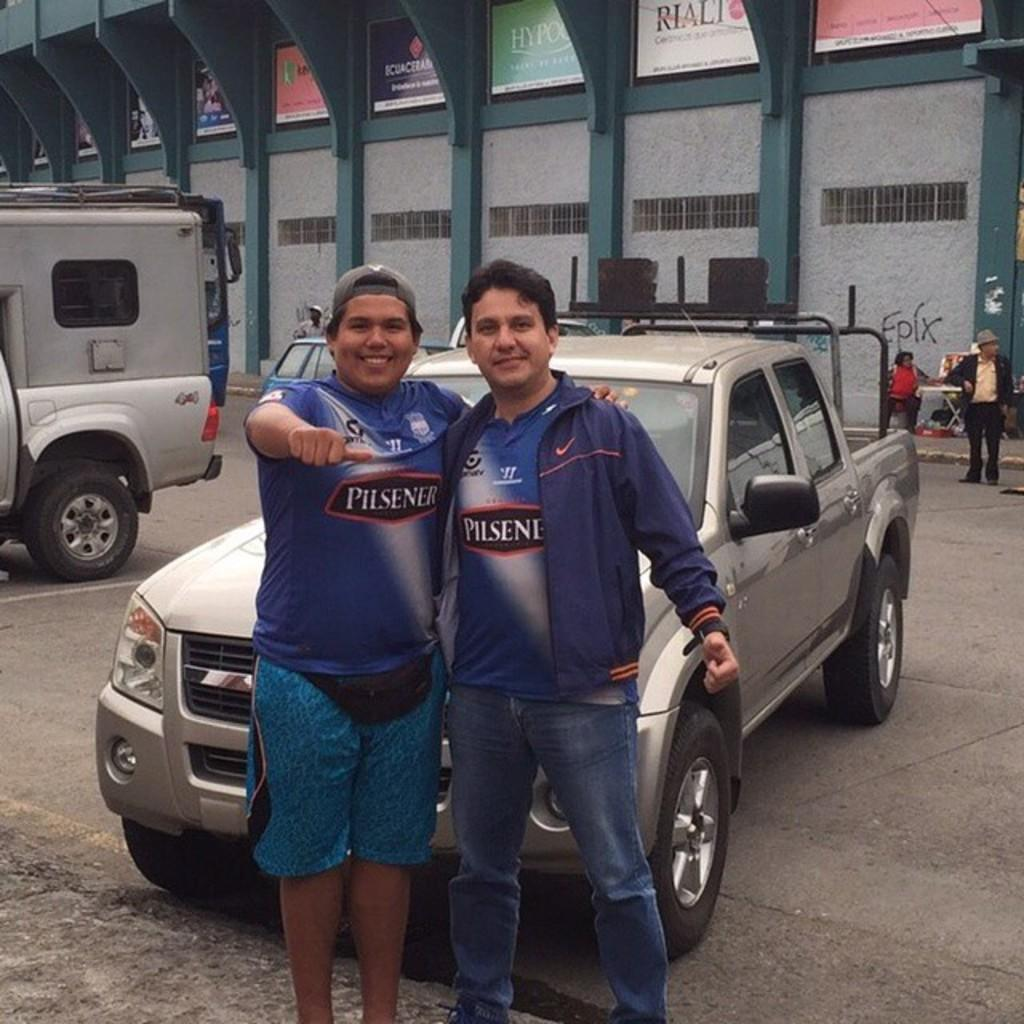How many persons can be seen in the image? There are persons in the image, but the exact number is not specified. What can be seen on the road in the image? There are vehicles on the road in the image. What type of structure is present in the image? There is a building in the image. What architectural feature is visible in the image? There are pillars in the image. What type of information is displayed on the boards in the image? There are boards with text in the image, but the content of the text is not specified. Can you see any caves in the image? There is no mention of a cave in the image, so it cannot be confirmed or denied. What type of rail system is present in the image? There is no rail system present in the image. Is the image covered in snow? There is no mention of snow in the image, so it cannot be confirmed or denied. 